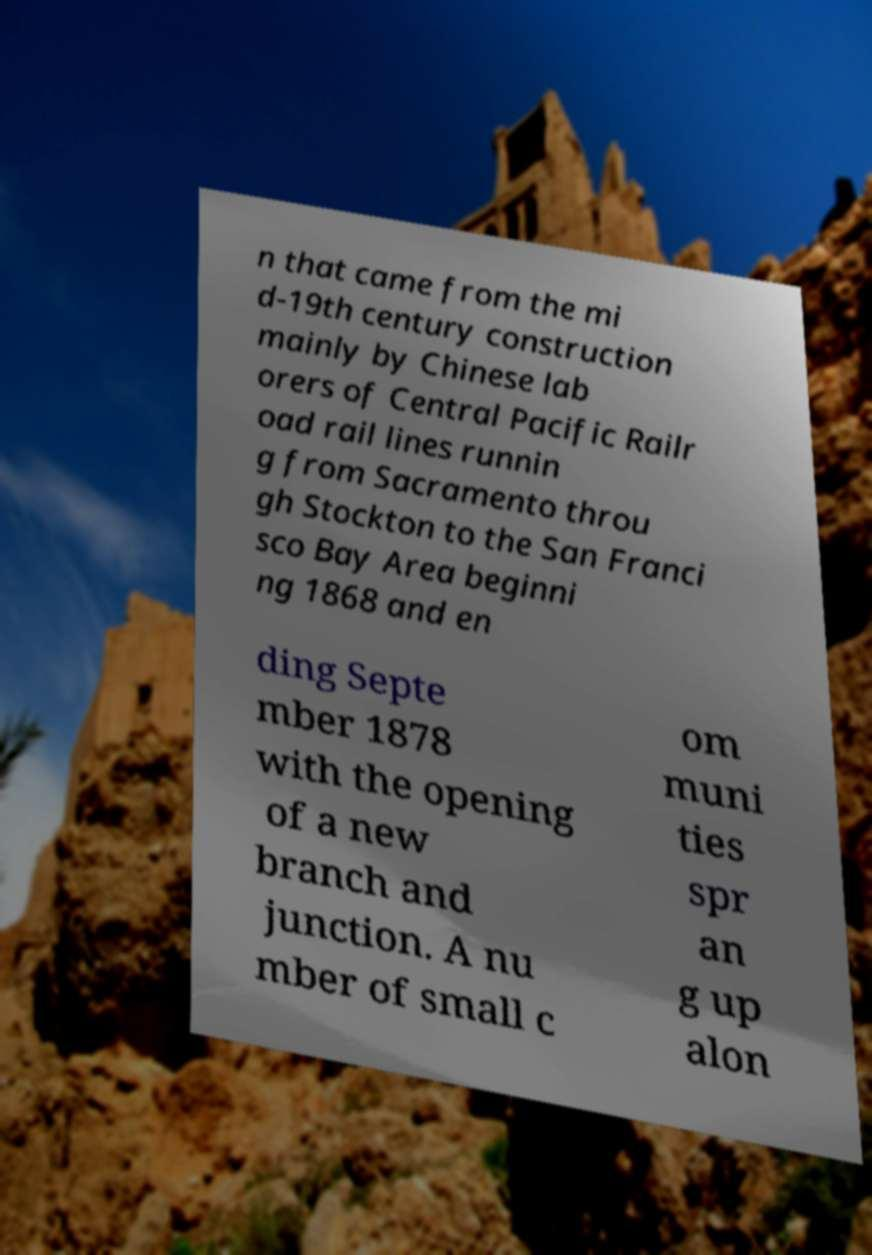Could you assist in decoding the text presented in this image and type it out clearly? n that came from the mi d-19th century construction mainly by Chinese lab orers of Central Pacific Railr oad rail lines runnin g from Sacramento throu gh Stockton to the San Franci sco Bay Area beginni ng 1868 and en ding Septe mber 1878 with the opening of a new branch and junction. A nu mber of small c om muni ties spr an g up alon 